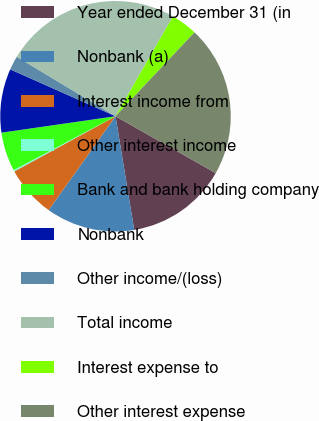Convert chart to OTSL. <chart><loc_0><loc_0><loc_500><loc_500><pie_chart><fcel>Year ended December 31 (in<fcel>Nonbank (a)<fcel>Interest income from<fcel>Other interest income<fcel>Bank and bank holding company<fcel>Nonbank<fcel>Other income/(loss)<fcel>Total income<fcel>Interest expense to<fcel>Other interest expense<nl><fcel>14.19%<fcel>12.45%<fcel>7.2%<fcel>0.21%<fcel>5.46%<fcel>8.95%<fcel>1.96%<fcel>24.68%<fcel>3.71%<fcel>21.19%<nl></chart> 